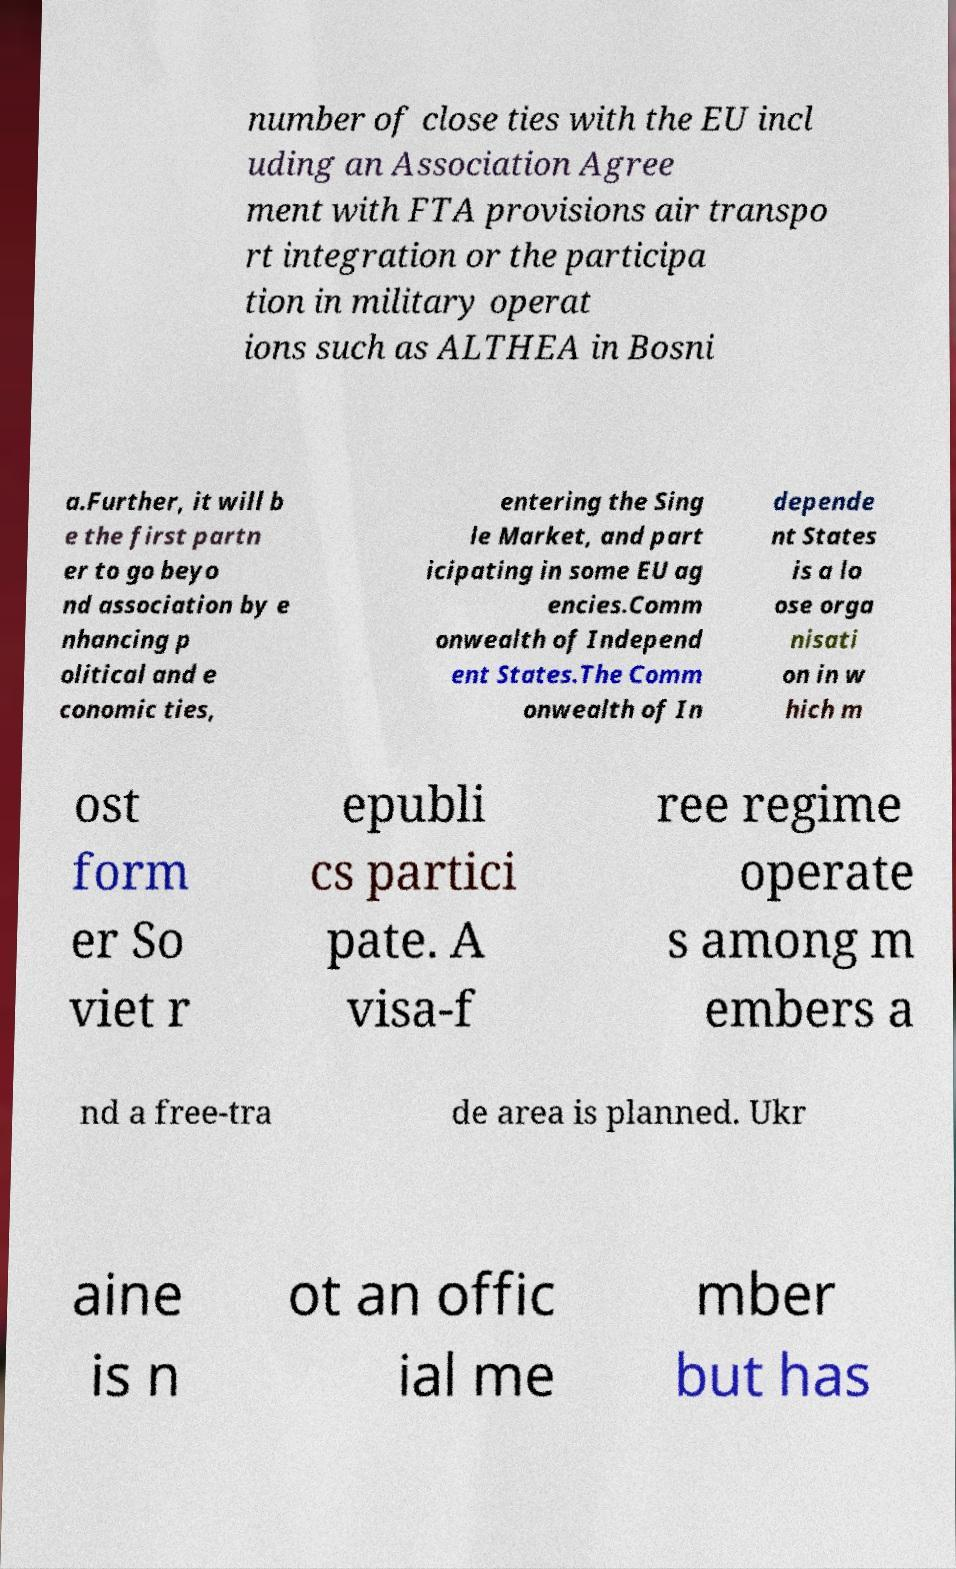For documentation purposes, I need the text within this image transcribed. Could you provide that? number of close ties with the EU incl uding an Association Agree ment with FTA provisions air transpo rt integration or the participa tion in military operat ions such as ALTHEA in Bosni a.Further, it will b e the first partn er to go beyo nd association by e nhancing p olitical and e conomic ties, entering the Sing le Market, and part icipating in some EU ag encies.Comm onwealth of Independ ent States.The Comm onwealth of In depende nt States is a lo ose orga nisati on in w hich m ost form er So viet r epubli cs partici pate. A visa-f ree regime operate s among m embers a nd a free-tra de area is planned. Ukr aine is n ot an offic ial me mber but has 